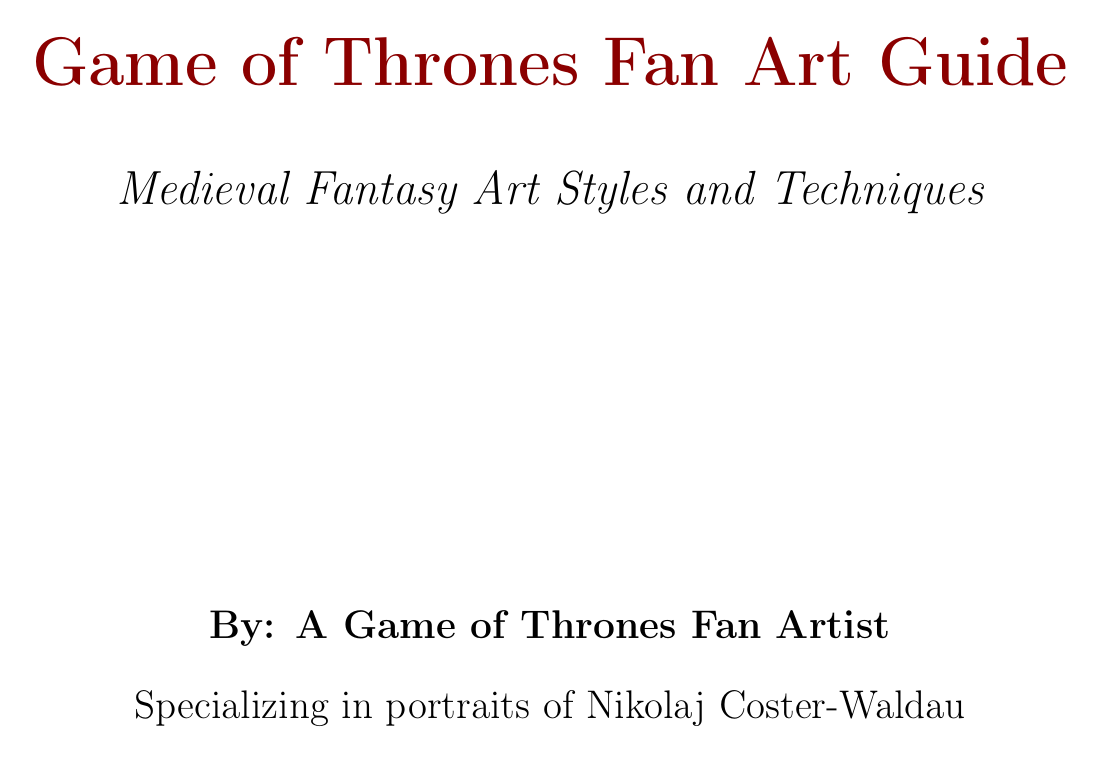what art style does the illuminated manuscript style draw inspiration from? The illuminated manuscript style is inspired by medieval illuminated manuscripts.
Answer: illuminated manuscripts what colors are included in the Lannister palette? The Lannister palette consists of crimson red, gold, deep burgundy, and ivory.
Answer: crimson red, gold, deep burgundy, ivory which composition technique emphasizes position of elements in a 3x3 grid? The technique that emphasizes positioning elements in a grid is known as the rule of thirds.
Answer: rule of thirds what software is mentioned for digital painting? The software mentioned for digital painting is Adobe Photoshop.
Answer: Adobe Photoshop what is the primary advantage of traditional watercolor techniques? The primary advantage of traditional watercolor techniques is creating a softer, more ethereal look for fantasy-inspired illustrations.
Answer: softer, more ethereal look how can environmental storytelling be utilized in fan art? Environmental storytelling can be utilized by using background elements to convey narrative information.
Answer: using background elements what type of characters can benefit from dynamic poses in fan art? Dynamic poses can capture characters in action or emotionally charged moments.
Answer: characters in action what is the importance of character reference materials? Character reference materials are vital for capturing accurate likenesses in character portraits.
Answer: capturing accurate likenesses 